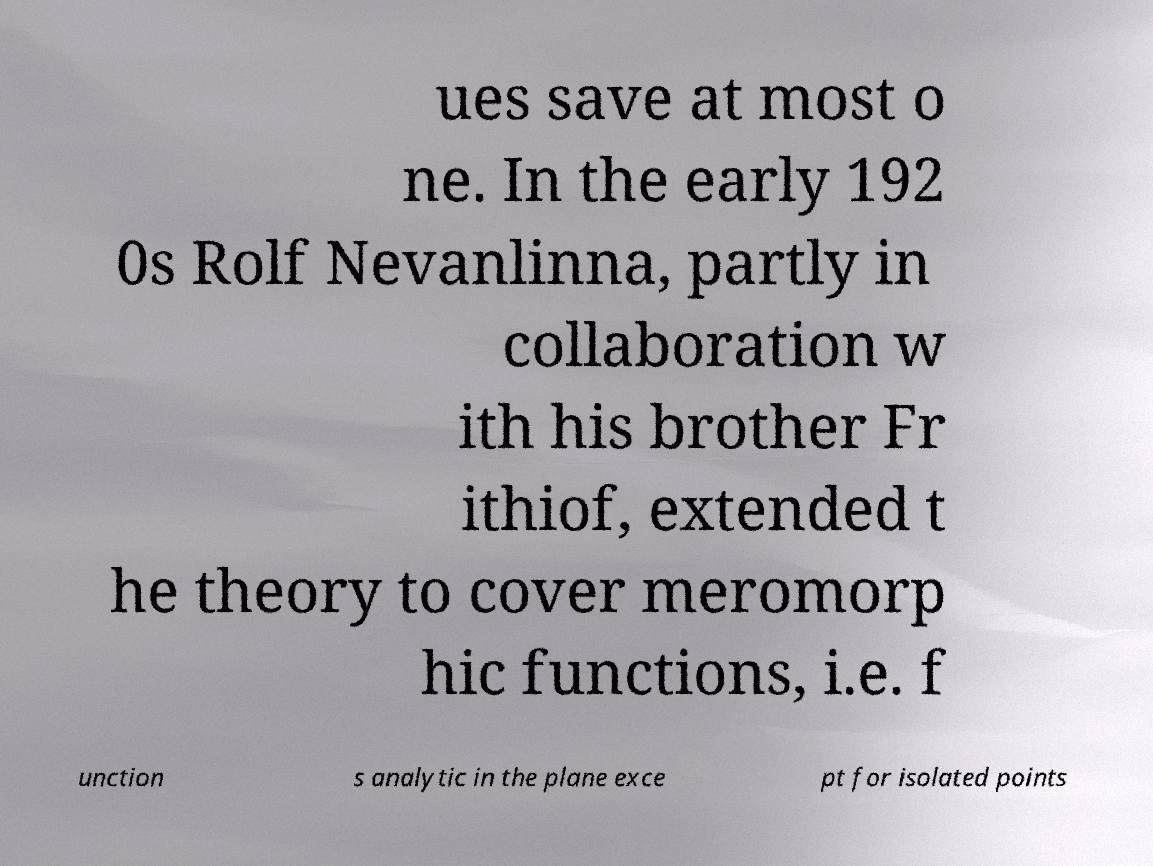Could you extract and type out the text from this image? ues save at most o ne. In the early 192 0s Rolf Nevanlinna, partly in collaboration w ith his brother Fr ithiof, extended t he theory to cover meromorp hic functions, i.e. f unction s analytic in the plane exce pt for isolated points 